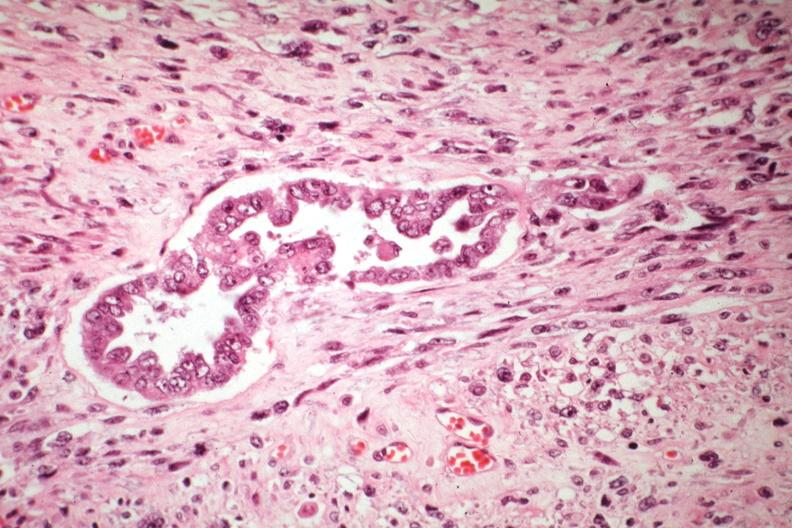s this good yellow color slide present?
Answer the question using a single word or phrase. No 